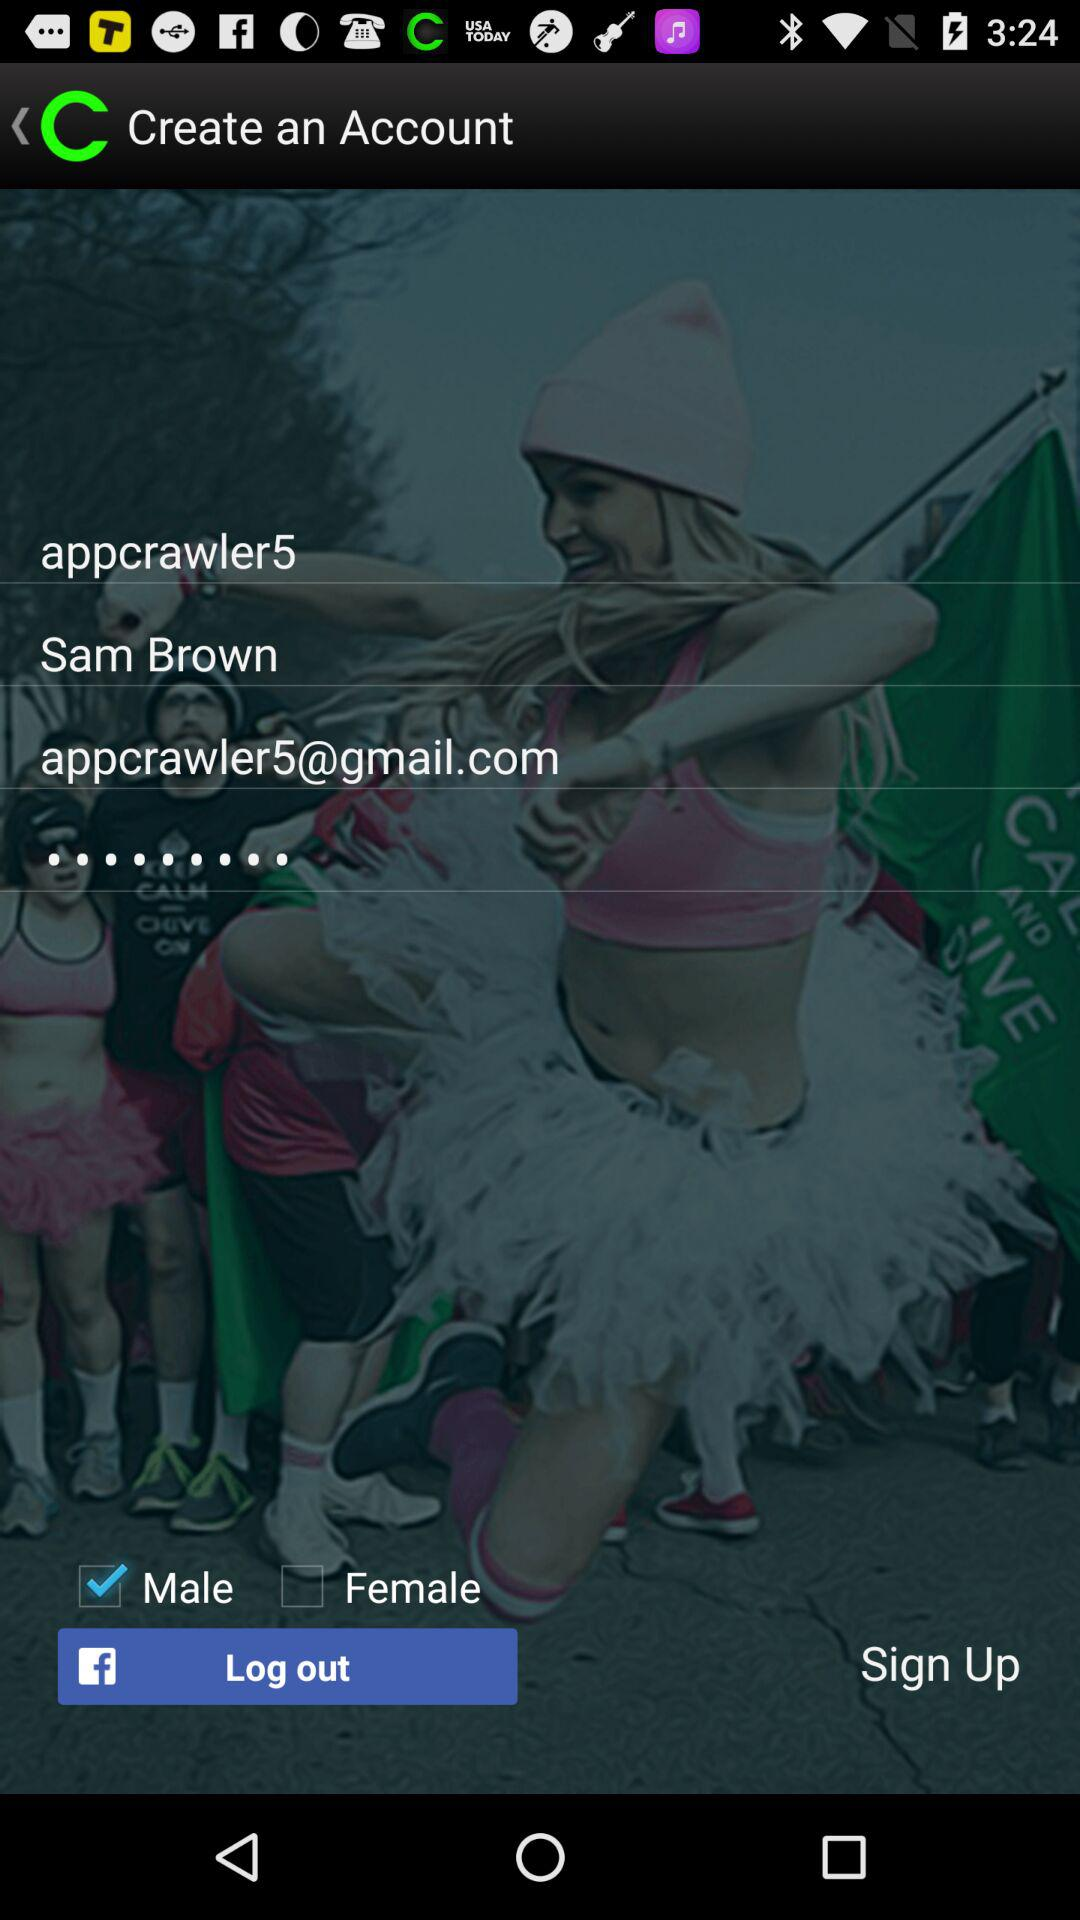What is the gender of the user? The gender is male. 